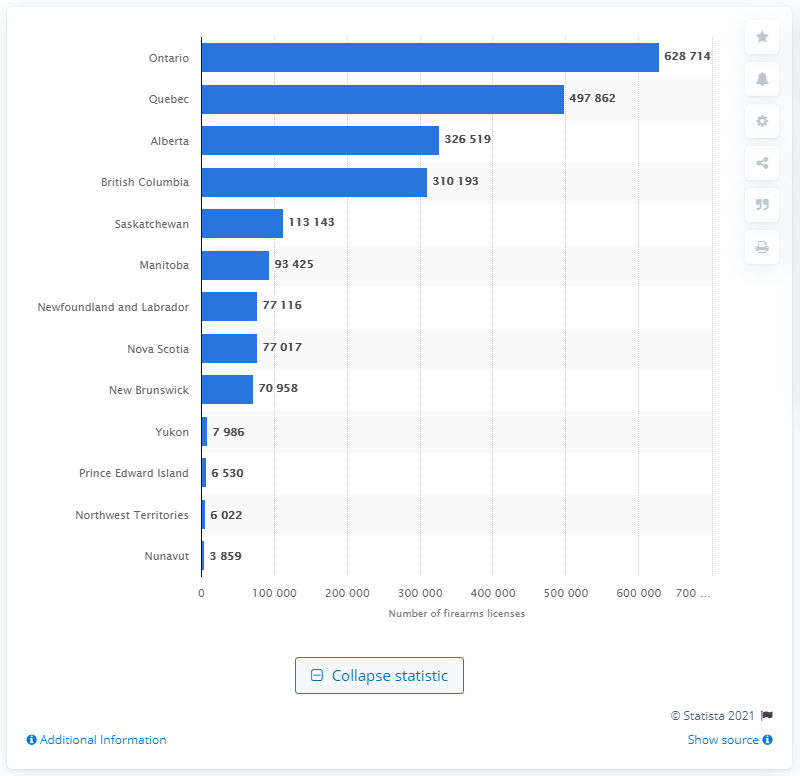Draw attention to some important aspects in this diagram. In 2019, there were a total of 628,714 firearms licenses held in the province of Ontario. 